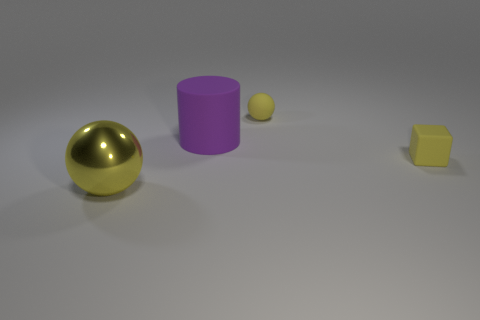There is a tiny rubber object behind the block; what number of big cylinders are left of it?
Offer a very short reply. 1. How many things are either rubber objects that are in front of the purple rubber thing or red rubber blocks?
Provide a succinct answer. 1. Is there a yellow rubber object that has the same shape as the purple matte object?
Ensure brevity in your answer.  No. There is a big object that is behind the yellow thing that is right of the rubber sphere; what shape is it?
Provide a short and direct response. Cylinder. How many cubes are small matte things or yellow objects?
Your answer should be very brief. 1. There is a tiny ball that is the same color as the large metallic sphere; what is its material?
Make the answer very short. Rubber. Does the tiny yellow matte thing behind the tiny yellow cube have the same shape as the yellow metallic thing in front of the small yellow sphere?
Keep it short and to the point. Yes. There is a thing that is both right of the large purple cylinder and behind the yellow matte block; what color is it?
Offer a very short reply. Yellow. There is a tiny block; does it have the same color as the ball that is left of the purple matte cylinder?
Your answer should be compact. Yes. How big is the yellow object that is in front of the rubber cylinder and to the right of the large purple cylinder?
Provide a succinct answer. Small. 